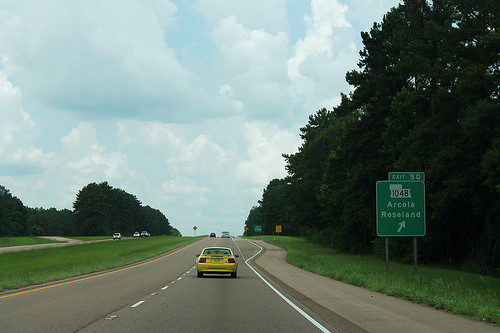<image>
Is the truck next to the gravel? No. The truck is not positioned next to the gravel. They are located in different areas of the scene. 